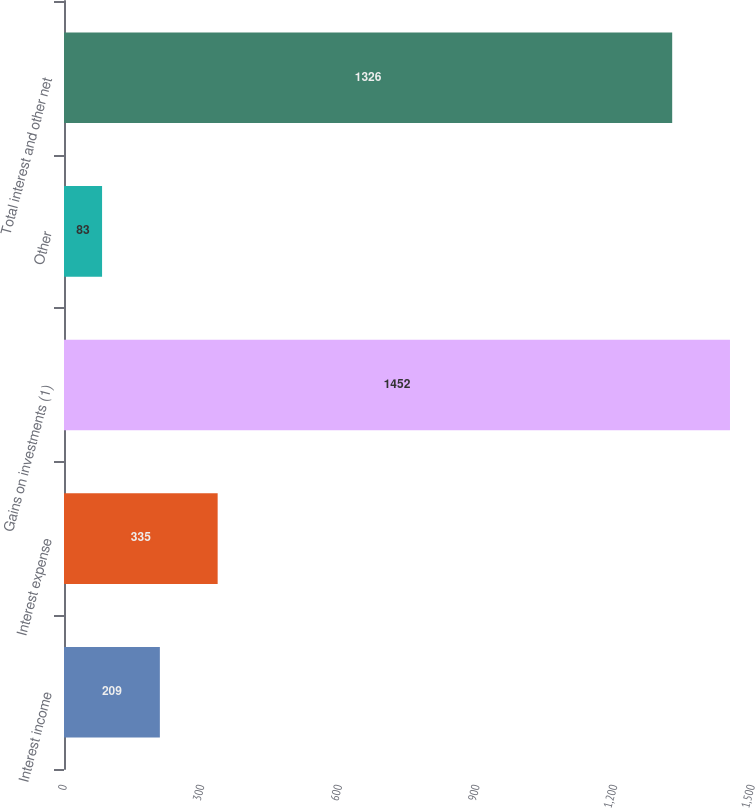Convert chart to OTSL. <chart><loc_0><loc_0><loc_500><loc_500><bar_chart><fcel>Interest income<fcel>Interest expense<fcel>Gains on investments (1)<fcel>Other<fcel>Total interest and other net<nl><fcel>209<fcel>335<fcel>1452<fcel>83<fcel>1326<nl></chart> 